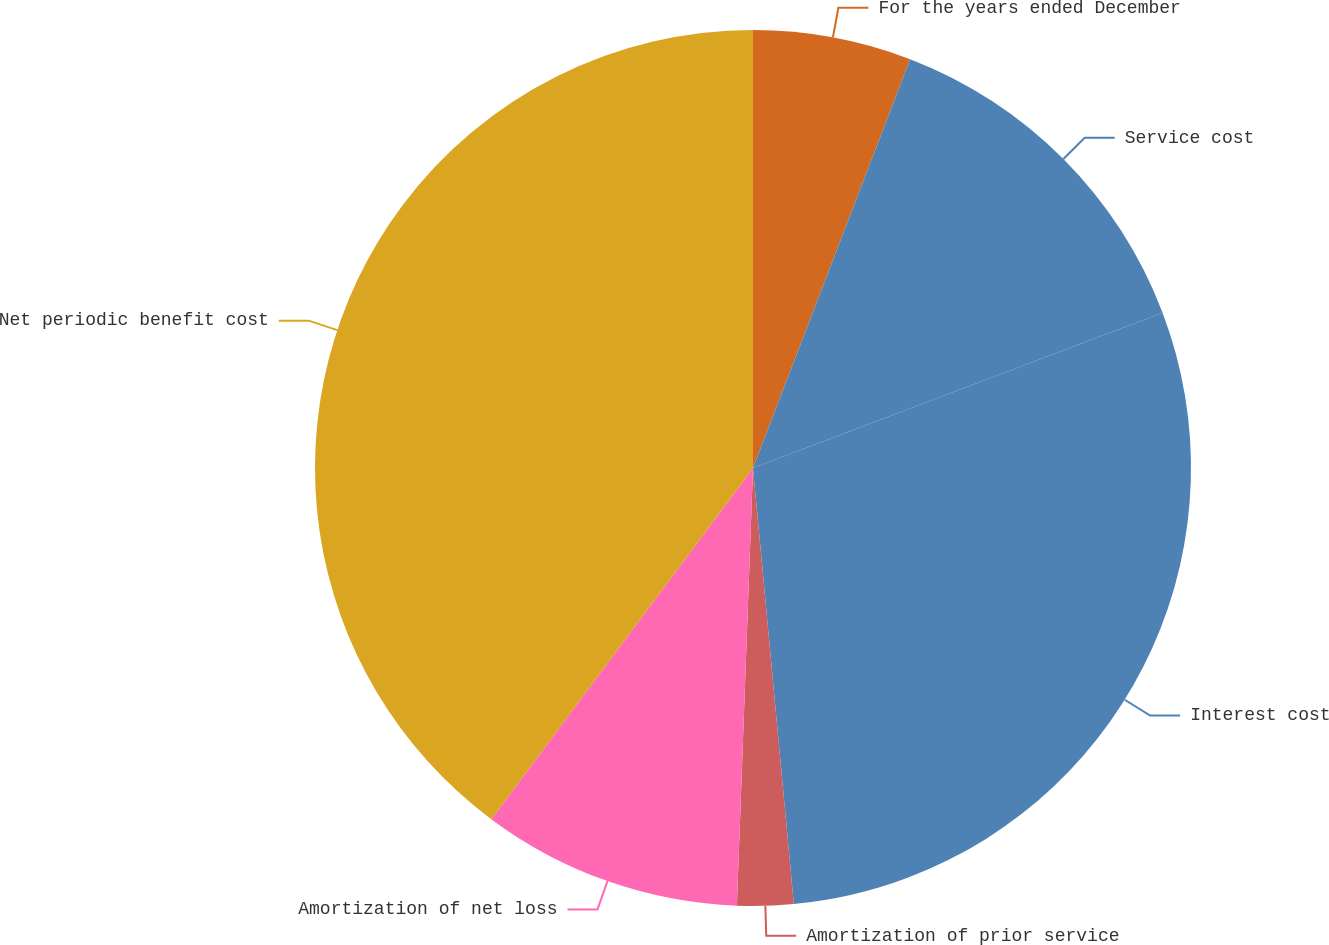Convert chart. <chart><loc_0><loc_0><loc_500><loc_500><pie_chart><fcel>For the years ended December<fcel>Service cost<fcel>Interest cost<fcel>Amortization of prior service<fcel>Amortization of net loss<fcel>Net periodic benefit cost<nl><fcel>5.84%<fcel>13.39%<fcel>29.28%<fcel>2.07%<fcel>9.61%<fcel>39.8%<nl></chart> 